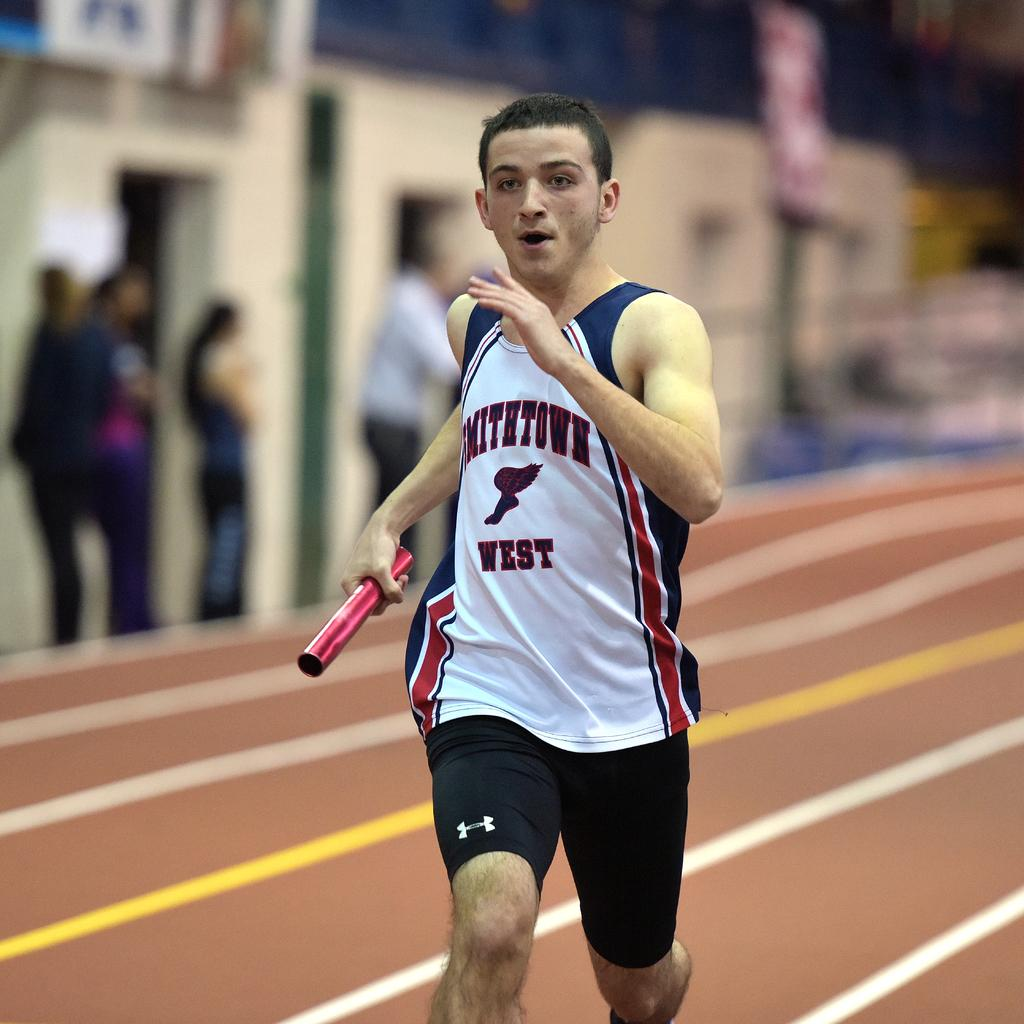<image>
Relay a brief, clear account of the picture shown. A man in a Smithtown west shirt runs down an indoor track. 